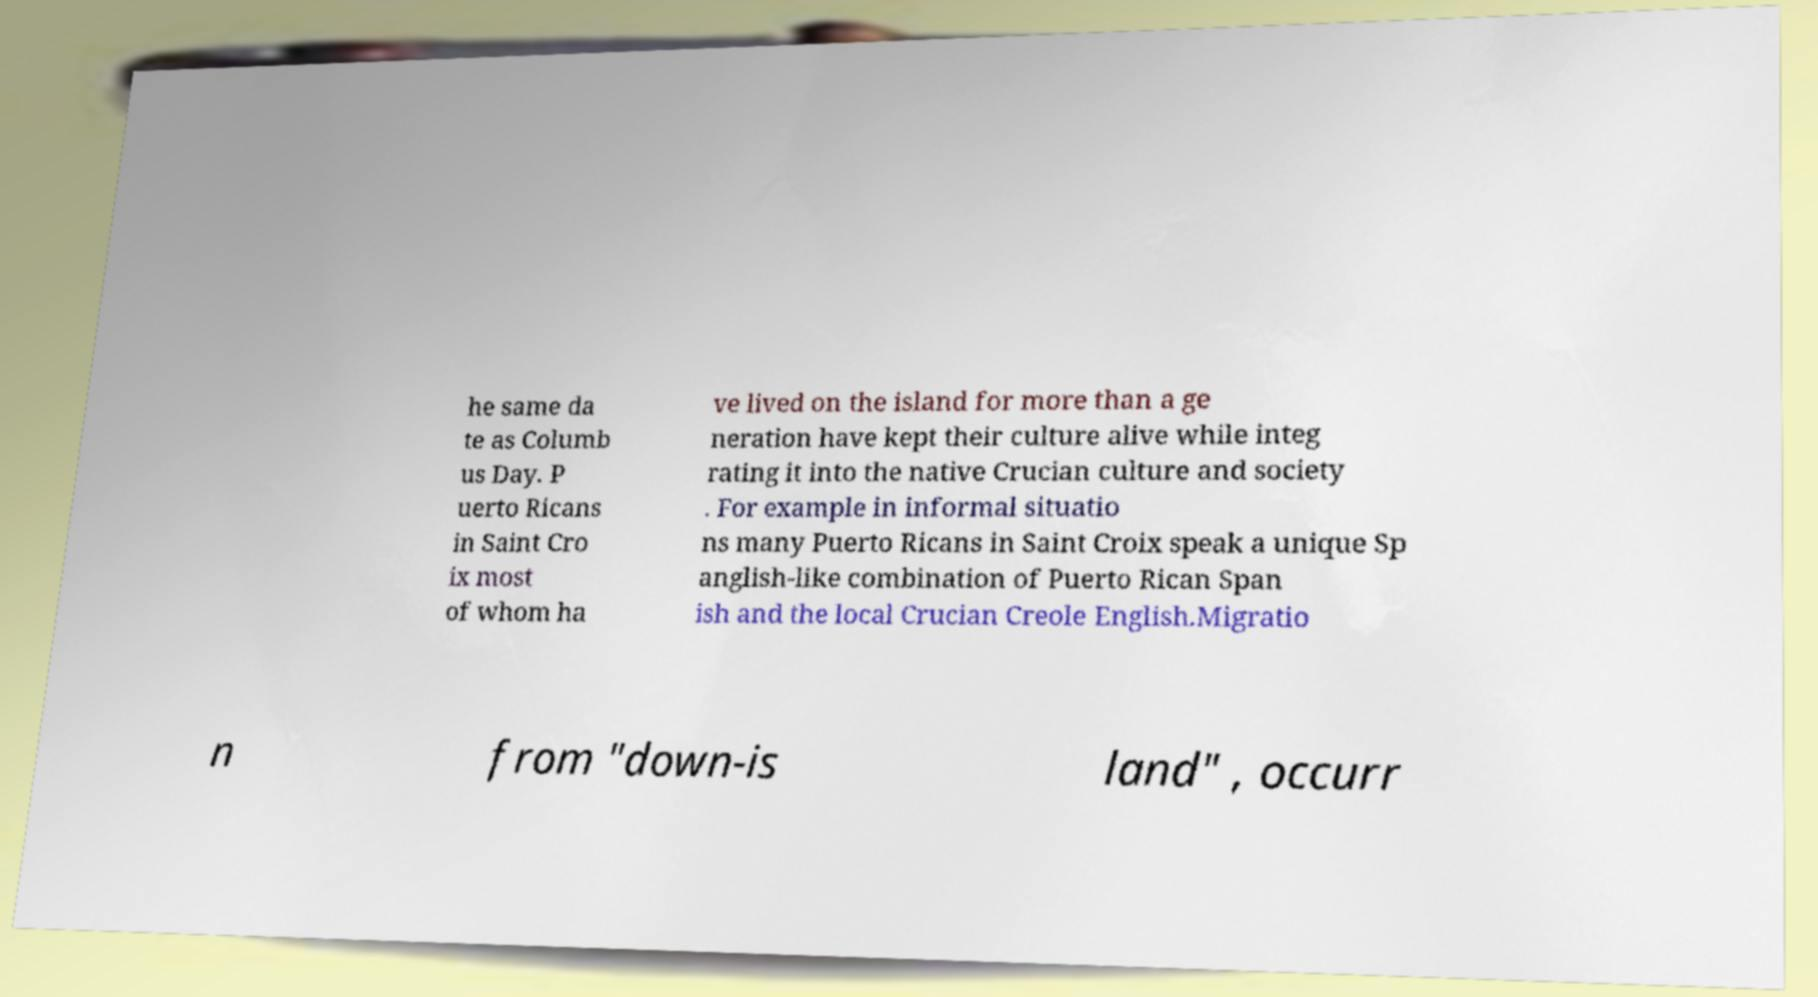For documentation purposes, I need the text within this image transcribed. Could you provide that? he same da te as Columb us Day. P uerto Ricans in Saint Cro ix most of whom ha ve lived on the island for more than a ge neration have kept their culture alive while integ rating it into the native Crucian culture and society . For example in informal situatio ns many Puerto Ricans in Saint Croix speak a unique Sp anglish-like combination of Puerto Rican Span ish and the local Crucian Creole English.Migratio n from "down-is land" , occurr 